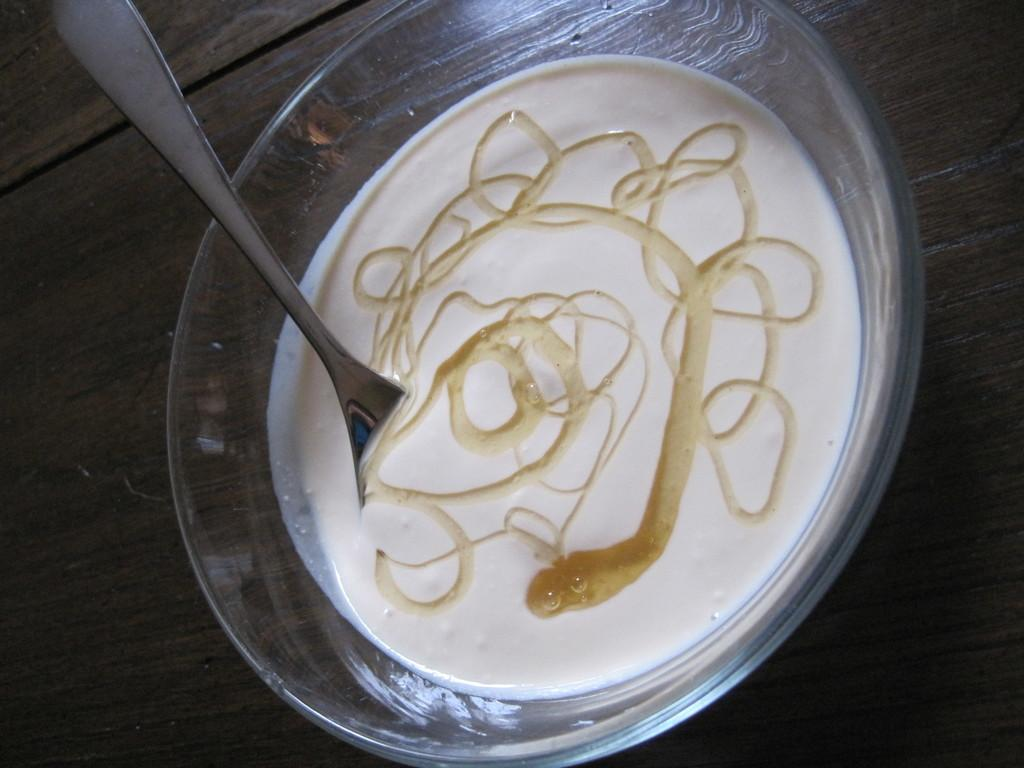What type of container is present in the image? There is a glass bowl in the image. What is inside the glass bowl? The glass bowl contains food. What utensil is visible in the image? There is a spoon in the image. What is the color of the surface beneath the glass bowl? The surface beneath the glass bowl is brown in color. What type of quiver is visible in the image? There is no quiver present in the image. How does the snow affect the visibility of the food in the glass bowl? There is no snow present in the image, so it does not affect the visibility of the food in the glass bowl. 